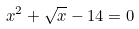Convert formula to latex. <formula><loc_0><loc_0><loc_500><loc_500>x ^ { 2 } + \sqrt { x } - 1 4 = 0</formula> 